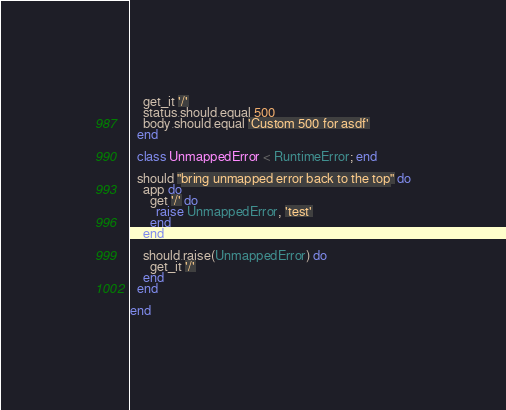<code> <loc_0><loc_0><loc_500><loc_500><_Ruby_>
    get_it '/'
    status.should.equal 500
    body.should.equal 'Custom 500 for asdf'
  end

  class UnmappedError < RuntimeError; end

  should "bring unmapped error back to the top" do
    app do
      get '/' do
        raise UnmappedError, 'test'
      end
    end

    should.raise(UnmappedError) do
      get_it '/'
    end
  end

end
</code> 